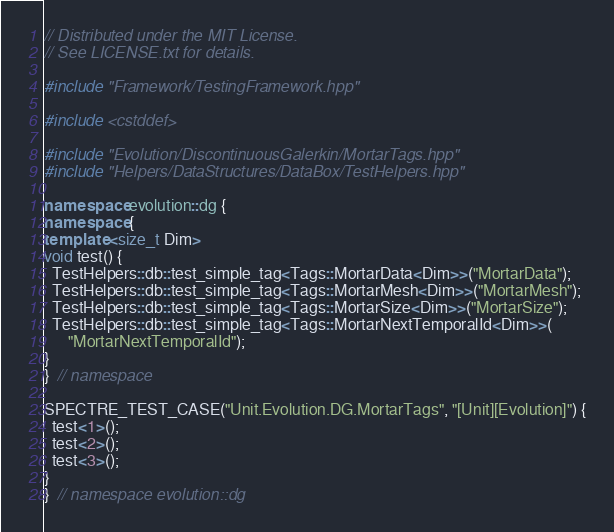Convert code to text. <code><loc_0><loc_0><loc_500><loc_500><_C++_>// Distributed under the MIT License.
// See LICENSE.txt for details.

#include "Framework/TestingFramework.hpp"

#include <cstddef>

#include "Evolution/DiscontinuousGalerkin/MortarTags.hpp"
#include "Helpers/DataStructures/DataBox/TestHelpers.hpp"

namespace evolution::dg {
namespace {
template <size_t Dim>
void test() {
  TestHelpers::db::test_simple_tag<Tags::MortarData<Dim>>("MortarData");
  TestHelpers::db::test_simple_tag<Tags::MortarMesh<Dim>>("MortarMesh");
  TestHelpers::db::test_simple_tag<Tags::MortarSize<Dim>>("MortarSize");
  TestHelpers::db::test_simple_tag<Tags::MortarNextTemporalId<Dim>>(
      "MortarNextTemporalId");
}
}  // namespace

SPECTRE_TEST_CASE("Unit.Evolution.DG.MortarTags", "[Unit][Evolution]") {
  test<1>();
  test<2>();
  test<3>();
}
}  // namespace evolution::dg
</code> 